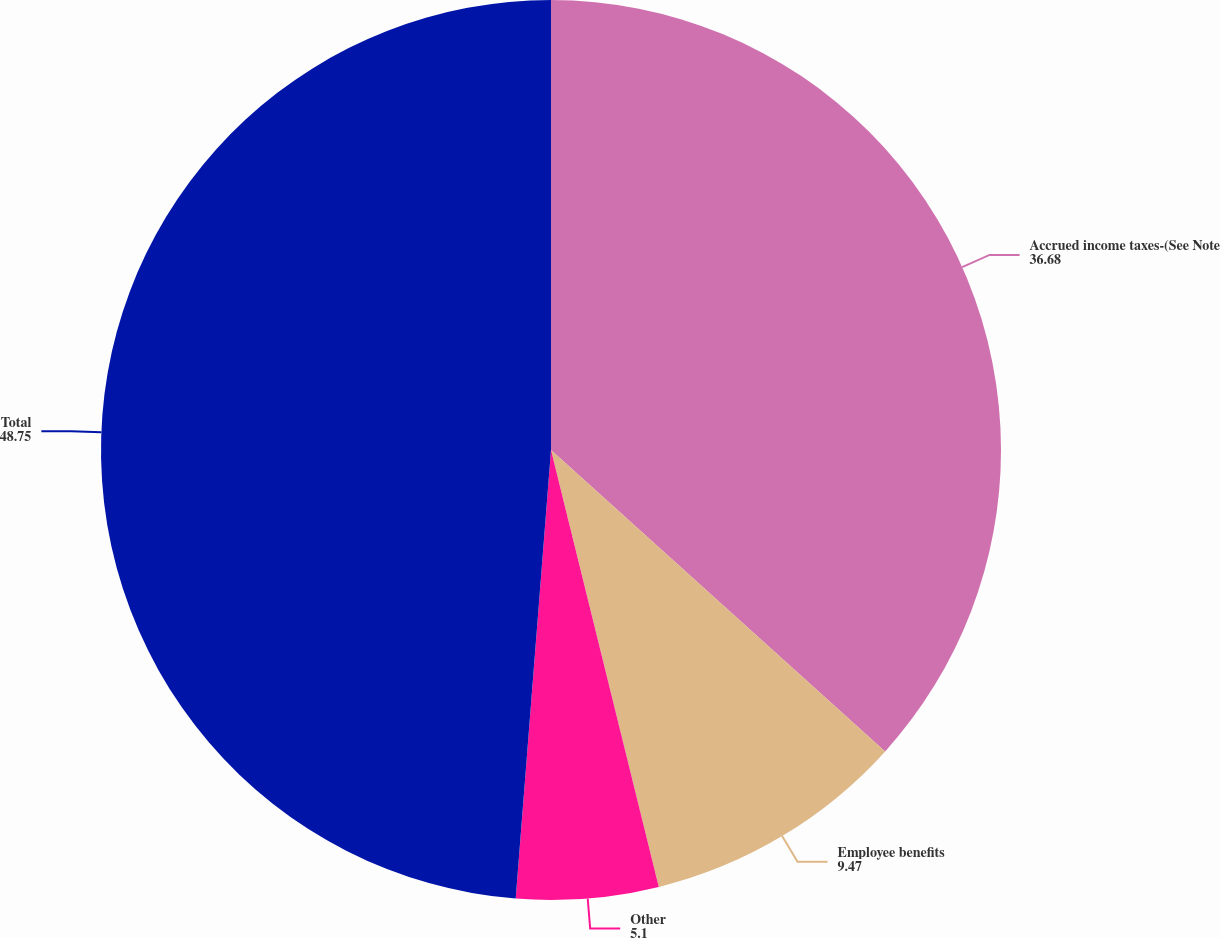<chart> <loc_0><loc_0><loc_500><loc_500><pie_chart><fcel>Accrued income taxes-(See Note<fcel>Employee benefits<fcel>Other<fcel>Total<nl><fcel>36.68%<fcel>9.47%<fcel>5.1%<fcel>48.75%<nl></chart> 